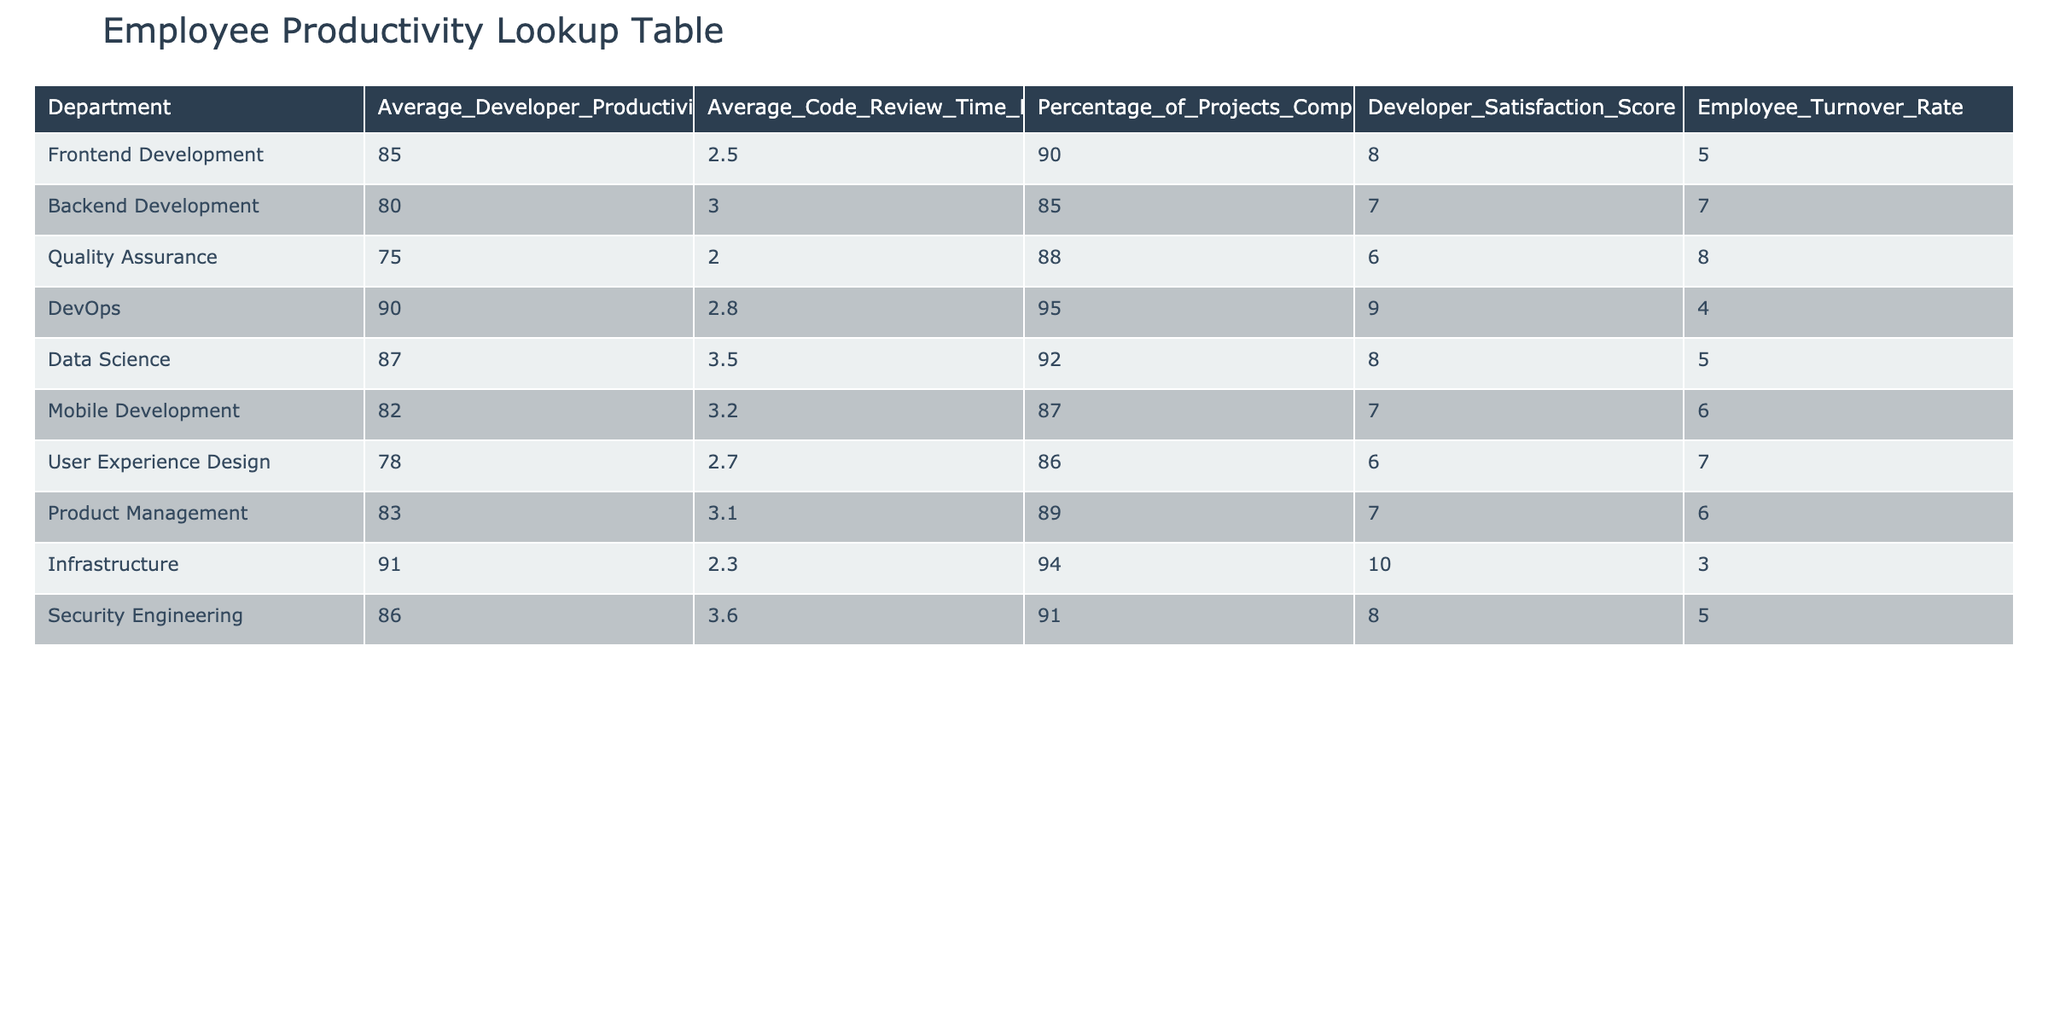What is the average developer productivity score for the Security Engineering department? The table shows the Average Developer Productivity Score for Security Engineering is listed as 86.
Answer: 86 Which department has the lowest employee turnover rate? By examining the Employee Turnover Rate column, Infrastructure has the lowest turnover rate at 3.
Answer: 3 What is the percentage of projects completed on time for the DevOps department? The table indicates that the Percentage of Projects Completed On Time for DevOps is 95.
Answer: 95 Calculate the average code review time across all departments. To find the average, sum up the Average Code Review Time Hours for all departments: (2.5 + 3.0 + 2.0 + 2.8 + 3.5 + 3.2 + 2.7 + 3.1 + 2.3 + 3.6) = 28.7, and divide by 10 (the number of departments) to get an average of 2.87 hours.
Answer: 2.87 Is the developer satisfaction score for Mobile Development higher than that of Quality Assurance? The Developer Satisfaction Score for Mobile Development is 7 and for Quality Assurance is 6. Since 7 is greater than 6, the answer is yes.
Answer: Yes What is the difference in the average developer productivity score between Frontend Development and Backend Development? The average productivity score for Frontend Development is 85 and for Backend Development is 80. The difference is 85 - 80 = 5.
Answer: 5 Which department has a higher Average Developer Productivity Score: Data Science or User Experience Design? Data Science has a productivity score of 87, while User Experience Design has a score of 78. Since 87 is greater than 78, Data Science has a higher score.
Answer: Data Science If the total number of projects in Frontend Development is 100, how many projects were completed on time? To find the number of projects completed on time, multiply the percentage of projects completed on time (90%) by the total projects (100): 90/100 * 100 = 90 projects completed on time.
Answer: 90 What is the average satisfaction score of departments with a turnover rate greater than 5? The departments with a turnover rate greater than 5 are Backend Development, Quality Assurance, Mobile Development, User Experience Design, and Security Engineering. Their satisfaction scores are 7, 6, 7, 6, and 8. Adding these scores gives 34, and dividing by 5 gives an average of 6.8.
Answer: 6.8 